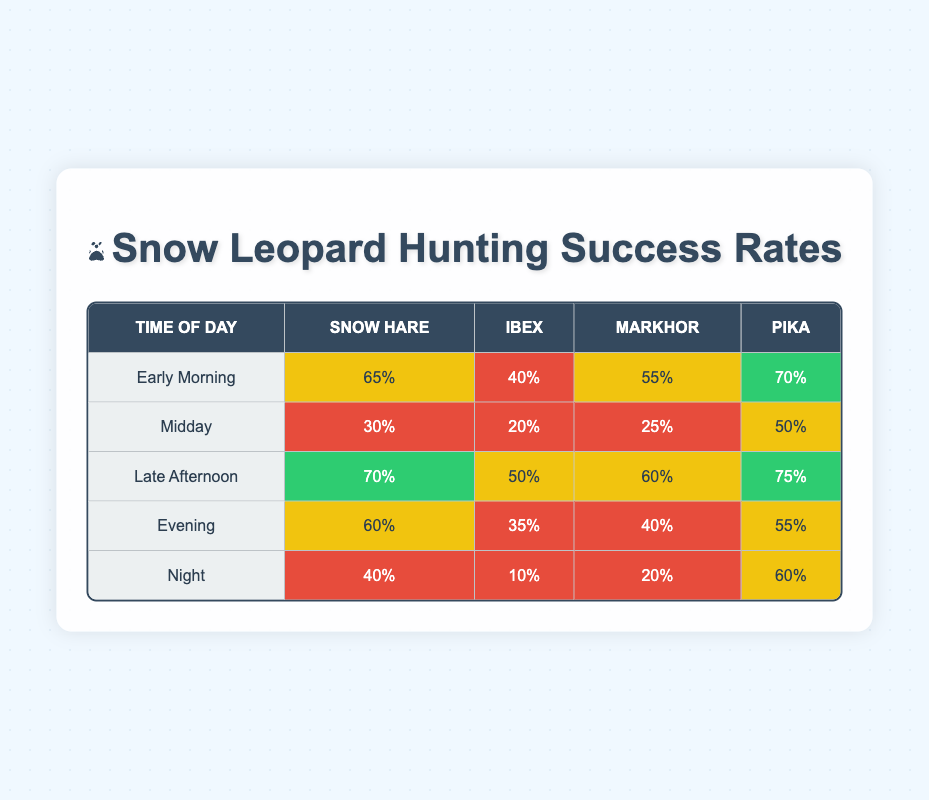What is the hunting success rate for Snow Hares during Late Afternoon? According to the table, the success rate for Snow Hares during Late Afternoon is listed as 70%.
Answer: 70% What time of day has the highest hunting success for Pikas? By examining the table, the highest success rate for Pikas is during Late Afternoon, which is 75%.
Answer: 75% True or False: The hunting success rate for Ibex is the same during Early Morning and Evening. The table indicates that the success rate for Ibex in Early Morning is 40%, while in Evening it is 35%. Therefore, they are not the same, making the statement false.
Answer: False What is the overall average hunting success rate for Snow Hares across all times of day? The success rates for Snow Hares are 65%, 30%, 70%, 60%, and 40%. To find the average, we add them: (65 + 30 + 70 + 60 + 40) = 265, and divide by 5, which equals 53.
Answer: 53 Which prey type has the lowest hunting success rate at Night? Looking at the Night row, the success rates for prey types are 40% for Snow Hares, 10% for Ibex, 20% for Markhor, and 60% for Pikas. The lowest is 10% for Ibex.
Answer: Ibex How much higher is the success rate of hunting Pikas during Early Morning compared to Midday? The success rate for Pikas in Early Morning is 70% and in Midday is 50%. The difference is 70% - 50% = 20%.
Answer: 20% During which time of day is the hunting success for Markhor the highest? The data shows that the highest hunting success rate for Markhor is during Late Afternoon at 60%.
Answer: Late Afternoon Comparing Early Morning and Late Afternoon, which time has a better success rate for Ibex? Early Morning has a success rate of 40%, while Late Afternoon has 50%. Since 50% is greater than 40%, Late Afternoon has a better success rate.
Answer: Late Afternoon Is the hunting success rate for Snow Hares higher than that for Markhor during the Evening? The success rate for Snow Hares in the Evening is 60% and for Markhor is 40%. Since 60% is greater than 40%, it means the statement is true.
Answer: True What is the total success rate for all types of prey during Midday? Summing the success rates for all prey during Midday: 30% (Snow Hares) + 20% (Ibex) + 25% (Markhor) + 50% (Pikas) = 125%.
Answer: 125% Which prey type shows the most variation in success rates between Early Morning and Night? Snow Hares have a success rate of 65% in Early Morning and 40% at Night, showing a variation of 25%. Pikas show a variation of 10% (70% to 60%). However, Snow Hares have the greatest difference, indicating more variation.
Answer: Snow Hares 